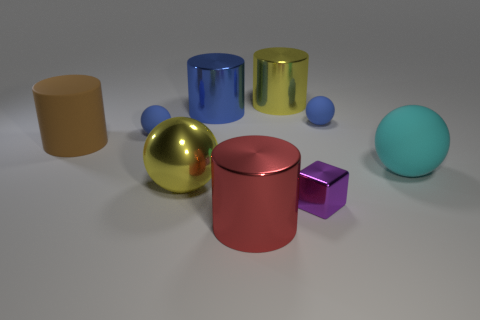What is the color of the matte cylinder that is the same size as the red shiny thing?
Your response must be concise. Brown. Are there fewer tiny blue balls to the left of the block than small rubber things right of the large yellow metal sphere?
Offer a terse response. No. What shape is the big yellow object that is in front of the large matte object that is on the left side of the large yellow object behind the large cyan ball?
Offer a very short reply. Sphere. Does the small rubber sphere right of the yellow sphere have the same color as the metallic thing to the left of the big blue metallic cylinder?
Keep it short and to the point. No. How many matte things are purple objects or big yellow balls?
Ensure brevity in your answer.  0. The large shiny cylinder in front of the small blue rubber thing to the right of the big yellow shiny object in front of the big blue metallic object is what color?
Offer a very short reply. Red. What color is the matte thing that is the same shape as the big blue metal thing?
Make the answer very short. Brown. Is there any other thing of the same color as the shiny sphere?
Your response must be concise. Yes. How many other objects are there of the same material as the cyan ball?
Provide a short and direct response. 3. The yellow sphere is what size?
Your answer should be very brief. Large. 